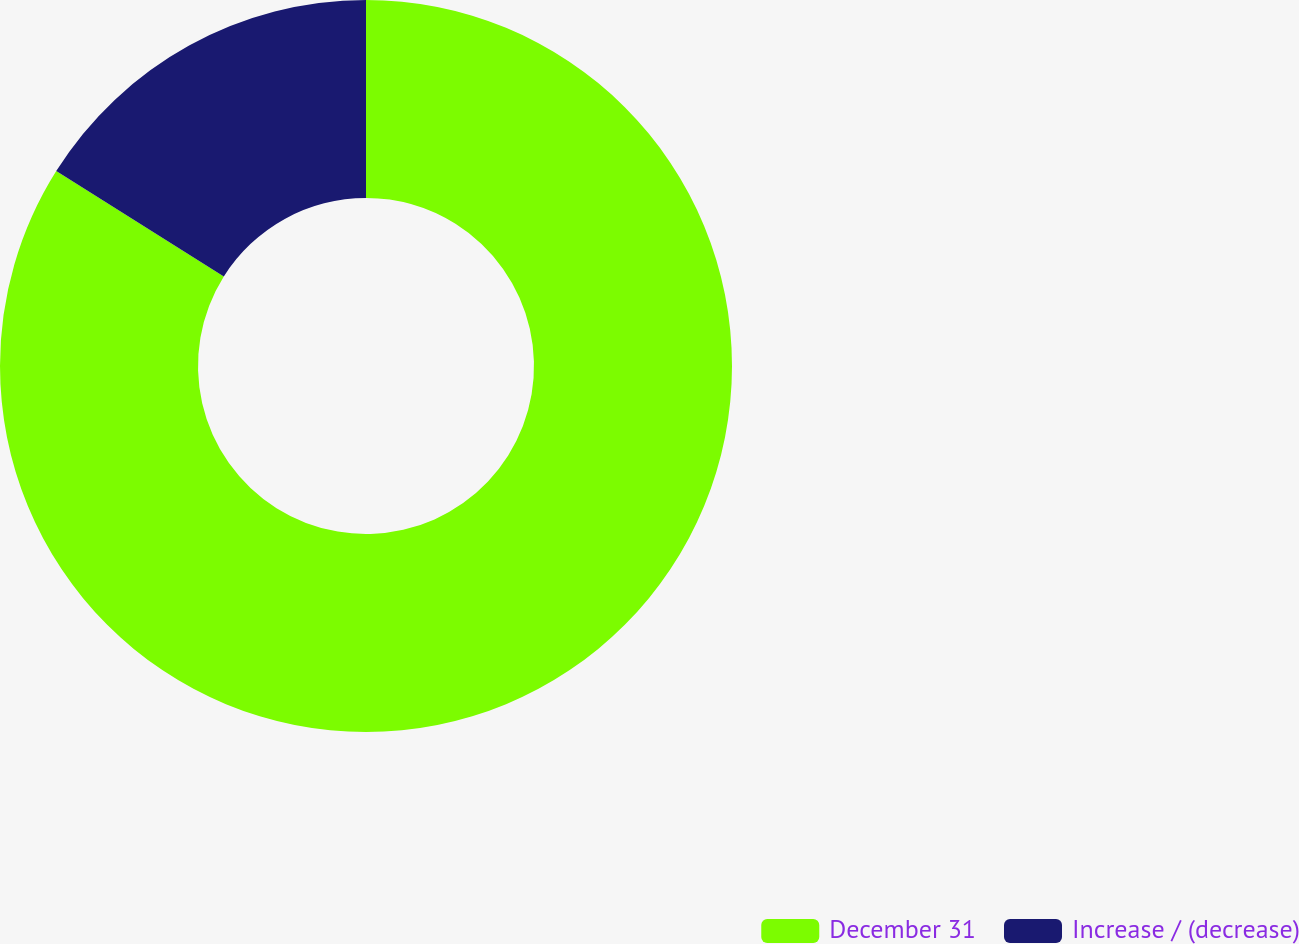Convert chart. <chart><loc_0><loc_0><loc_500><loc_500><pie_chart><fcel>December 31<fcel>Increase / (decrease)<nl><fcel>83.94%<fcel>16.06%<nl></chart> 